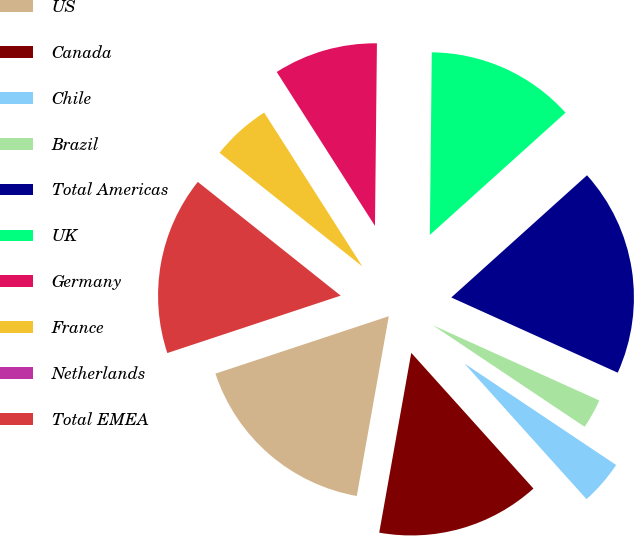<chart> <loc_0><loc_0><loc_500><loc_500><pie_chart><fcel>US<fcel>Canada<fcel>Chile<fcel>Brazil<fcel>Total Americas<fcel>UK<fcel>Germany<fcel>France<fcel>Netherlands<fcel>Total EMEA<nl><fcel>17.1%<fcel>14.47%<fcel>3.95%<fcel>2.63%<fcel>18.42%<fcel>13.16%<fcel>9.21%<fcel>5.26%<fcel>0.0%<fcel>15.79%<nl></chart> 